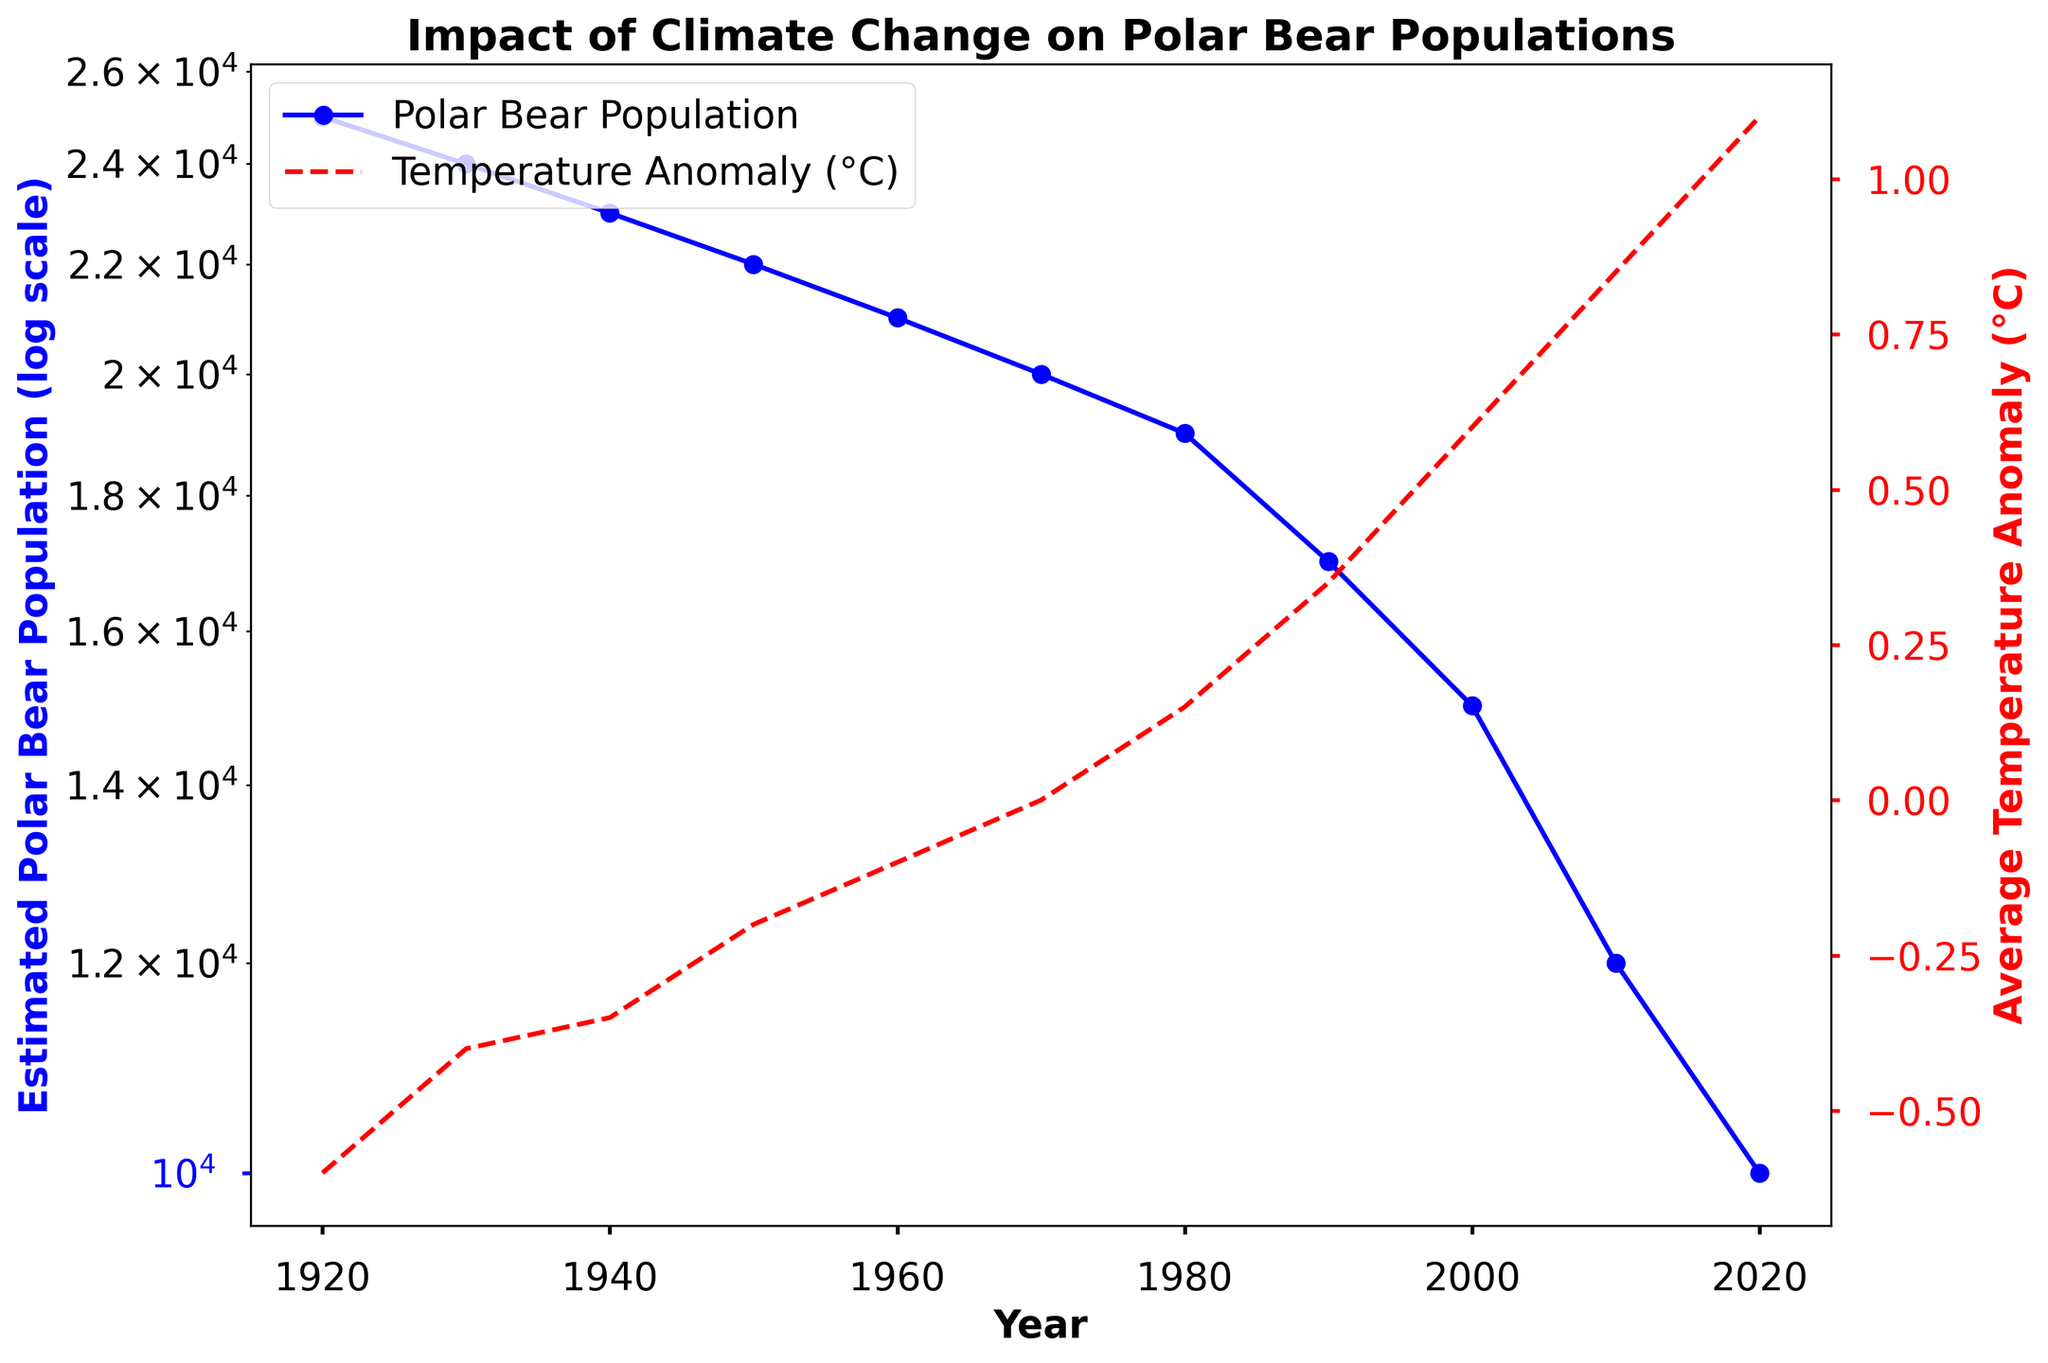what is the overall trend in the polar bear population over the past century? The blue line representing the estimated polar bear population on the log scale graph decreases steadily from 1920 to 2020, indicating a significant decline over the past century.
Answer: Decline How does the temperature anomaly in 1930 compare to that in 2020? The red dashed line shows that the average temperature anomaly increased from approximately -0.40°C in 1930 to 1.1°C in 2020, indicating a significant rise in temperature.
Answer: Increased by 1.5°C In which decade did the polar bear population experience the steepest decline? The steepest decline in the polar bear population occurs from 2000 to 2010, visible as the sharpest downward slope in the blue line on the log scale graph.
Answer: 2000-2010 What is the difference between the estimated polar bear population in 1950 and 2020? The population in 1950 is approximately 22,000, whereas in 2020, it is around 10,000. The difference is 22,000 - 10,000.
Answer: 12,000 How did the polar bear population change from 1980 to 1990? From the visual graph, the estimated population dropped from about 19,000 in 1980 to 17,000 in 1990, indicating a decrease.
Answer: Decreased by 2,000 At what temperature anomaly value does the estimated polar bear population drop below 20,000? Observing the red and blue lines, the population drops below 20,000 around 1970 when the temperature anomaly is at approximately 0.0°C.
Answer: 0.0°C Which year had an estimated polar bear population closest to 25,000? In 1920, the estimated polar bear population was closest to 25,000, as indicated on the blue line.
Answer: 1920 How does the temperature anomaly in 1940 compare to that in 2010? In 1940, the temperature anomaly was approximately -0.35°C, and in 2010, it was around 0.85°C. The difference in anomaly is 0.85°C - (-0.35°C).
Answer: Increased by 1.2°C When was the polar bear population closest to 20,000? In 1970, the estimated polar bear population was closest to 20,000, as shown on the blue line.
Answer: 1970 What is the combined effect on the polar bear population and temperature anomaly over the century? The blue line demonstrates a significant decline in the polar bear population, while the red dashed line indicates a consistent increase in temperature anomaly, suggesting a negative impact of rising temperatures on the polar bear population.
Answer: Decline in population, rise in temperature anomaly 